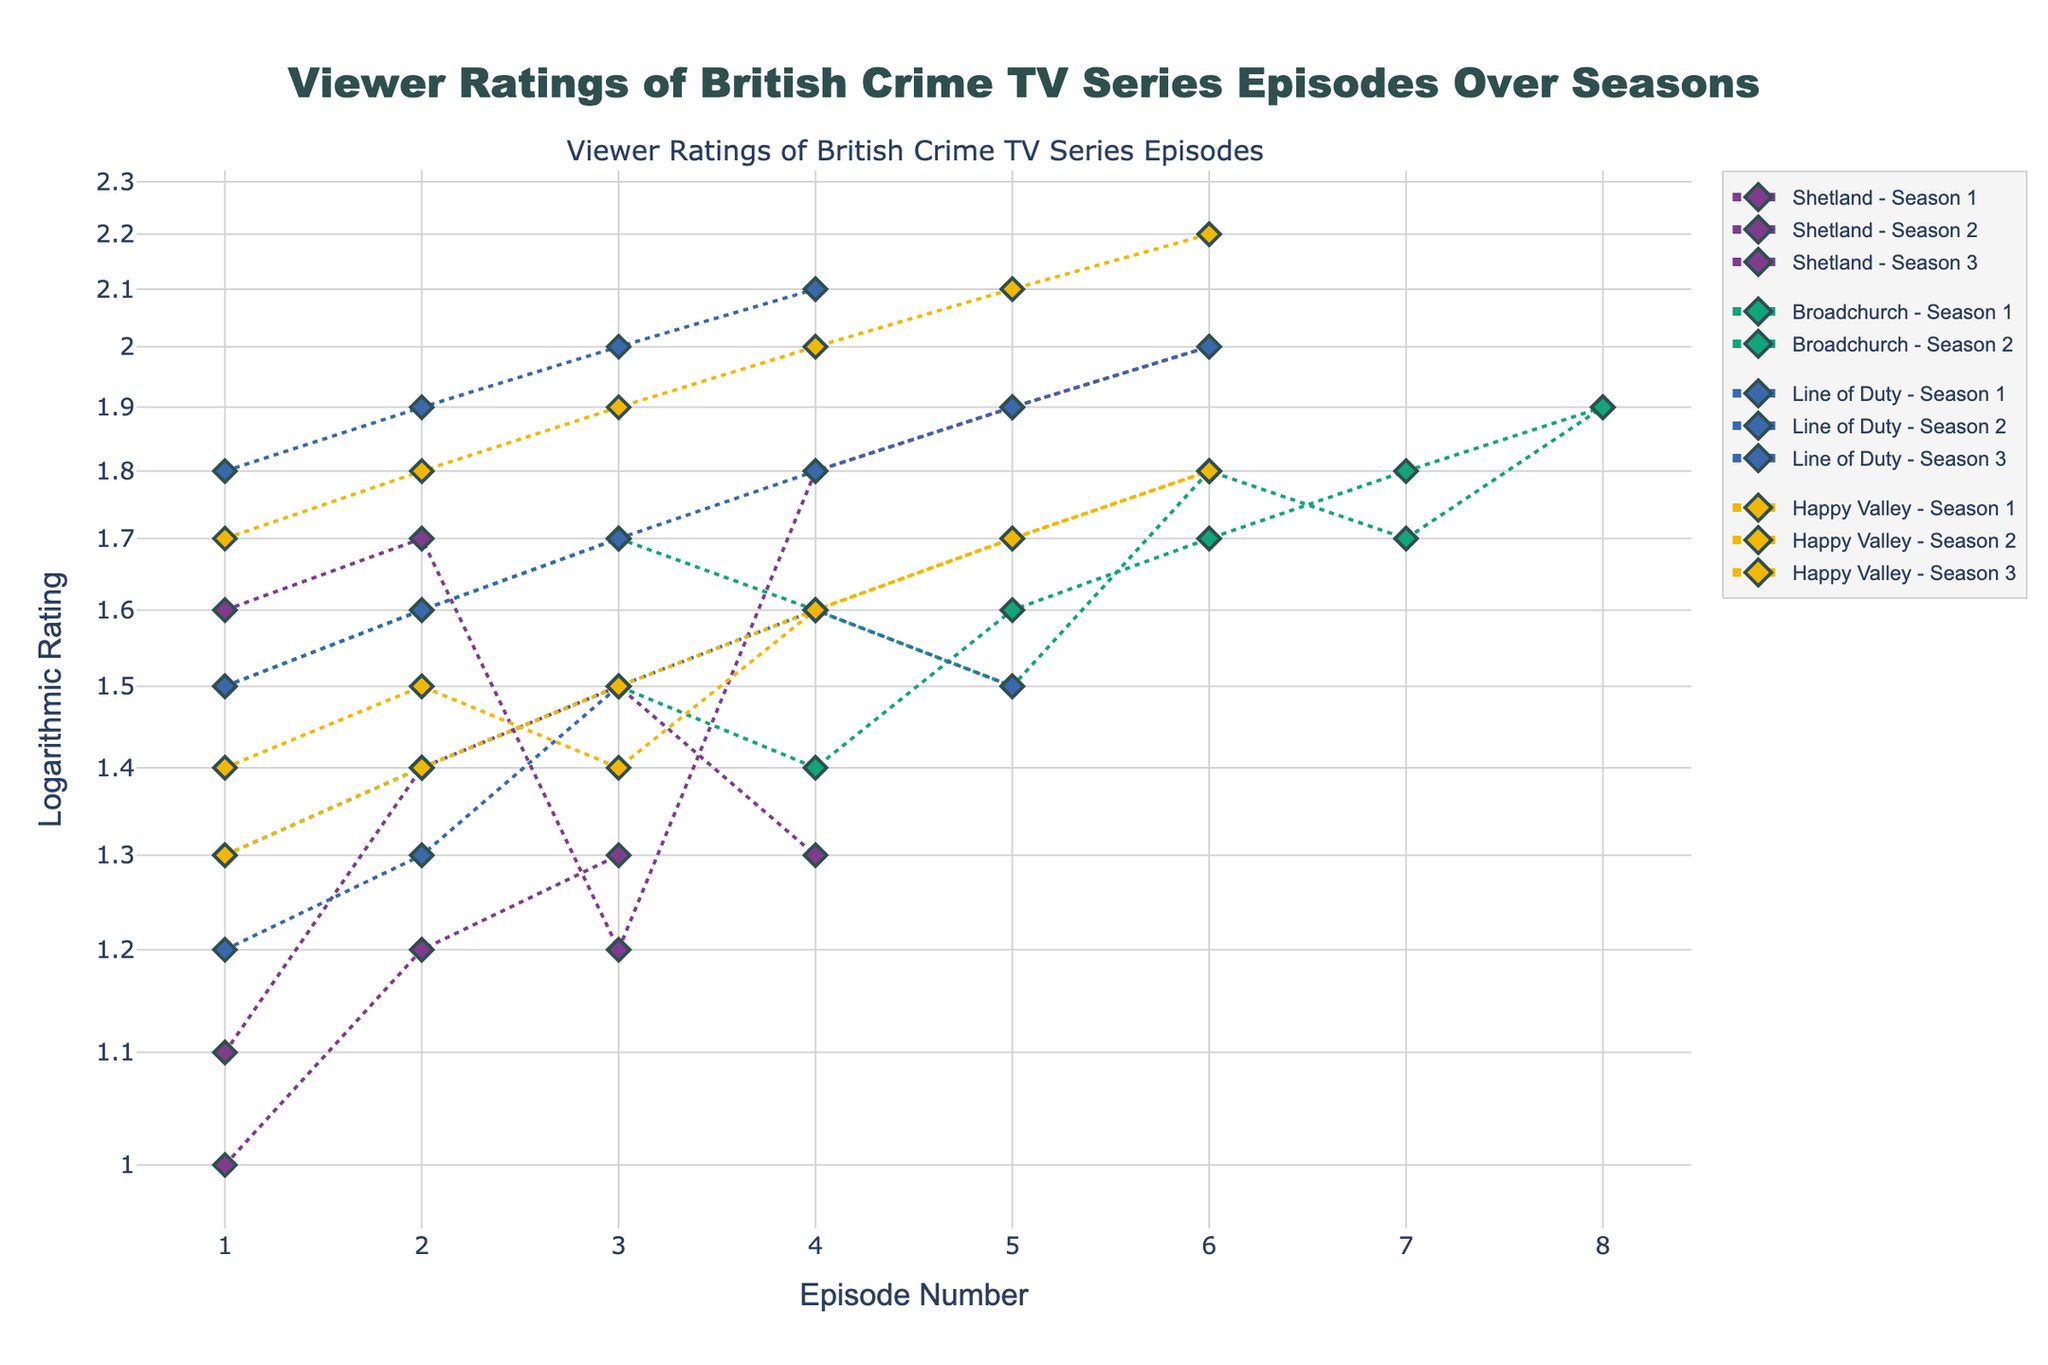What is the title of the plot? The title of the plot is displayed at the top. It reads "Viewer Ratings of British Crime TV Series Episodes Over Seasons."
Answer: Viewer Ratings of British Crime TV Series Episodes Over Seasons What does the y-axis represent in the plot? The y-axis represents 'Logarithmic Rating,' as indicated by the y-axis title.
Answer: Logarithmic Rating Which series has the highest logarithmic rating for any episode? By examining all the points, the highest y-value (logarithmic rating) appears in "Happy Valley" with a value of 2.2.
Answer: Happy Valley For Shetland Season 3, during which episode does the logarithmic rating reach 1.9? Locate the markers and lines corresponding to Shetland Season 3. The episode with a logarithmic rating of 1.9 is Episode 5.
Answer: Episode 5 How does the overall trend of logarithmic ratings change across seasons for Line of Duty? Observe the markers for Line of Duty across different seasons. It shows an increasing trend in logarithmic ratings, peaking at Season 2, Episode 4, with ratings gradually increasing and stabilizing at higher values.
Answer: Increasing Which series shows more consistency in viewer ratings over its seasons, Broadchurch or Happy Valley? Compare the variability of logarithmic ratings for Broadchurch and Happy Valley. Broadchurch has tighter groupings between 1.4 and 1.9, whereas Happy Valley's ratings range more widely from 1.3 to 2.2.
Answer: Broadchurch What is the average logarithmic rating for Shetland's Season 2 episodes? Calculate the arithmetic mean of the logarithmic ratings for Shetland Season 2 (1.1, 1.4, 1.5, 1.3). The sum is 5.3, and there are 4 episodes, giving an average of 5.3/4 = 1.325.
Answer: 1.325 